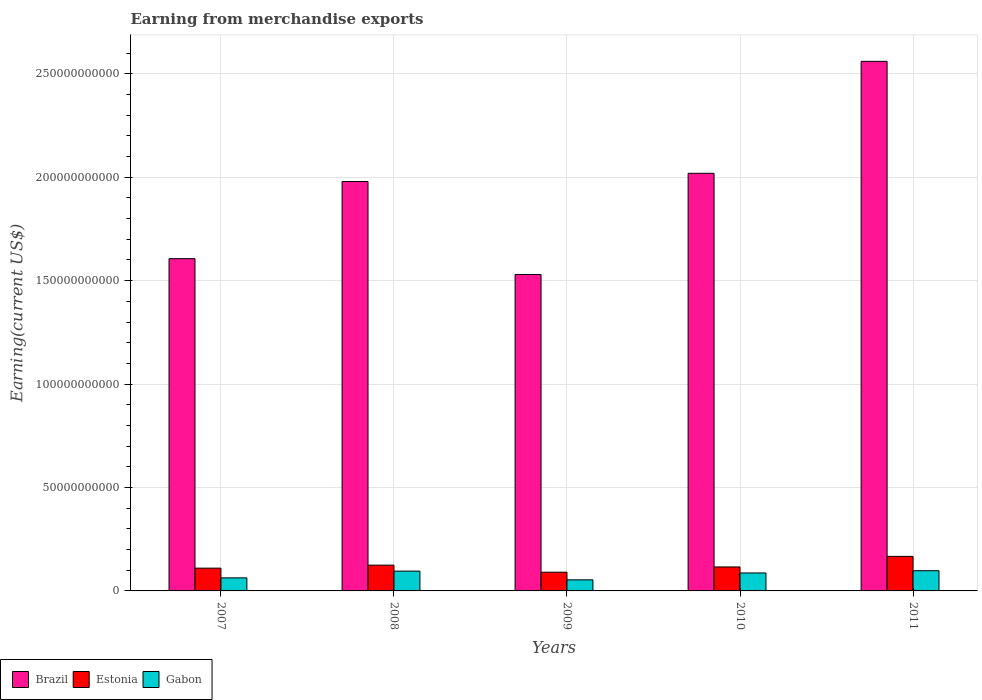How many groups of bars are there?
Provide a short and direct response. 5. Are the number of bars per tick equal to the number of legend labels?
Ensure brevity in your answer.  Yes. How many bars are there on the 2nd tick from the left?
Offer a very short reply. 3. What is the label of the 1st group of bars from the left?
Offer a very short reply. 2007. What is the amount earned from merchandise exports in Gabon in 2011?
Your response must be concise. 9.77e+09. Across all years, what is the maximum amount earned from merchandise exports in Gabon?
Ensure brevity in your answer.  9.77e+09. Across all years, what is the minimum amount earned from merchandise exports in Gabon?
Your answer should be compact. 5.36e+09. In which year was the amount earned from merchandise exports in Brazil maximum?
Offer a very short reply. 2011. What is the total amount earned from merchandise exports in Gabon in the graph?
Give a very brief answer. 3.97e+1. What is the difference between the amount earned from merchandise exports in Estonia in 2007 and that in 2008?
Provide a short and direct response. -1.45e+09. What is the difference between the amount earned from merchandise exports in Estonia in 2010 and the amount earned from merchandise exports in Gabon in 2009?
Your answer should be compact. 6.23e+09. What is the average amount earned from merchandise exports in Gabon per year?
Your answer should be compact. 7.94e+09. In the year 2009, what is the difference between the amount earned from merchandise exports in Estonia and amount earned from merchandise exports in Gabon?
Ensure brevity in your answer.  3.69e+09. What is the ratio of the amount earned from merchandise exports in Estonia in 2007 to that in 2009?
Provide a short and direct response. 1.22. Is the amount earned from merchandise exports in Brazil in 2007 less than that in 2011?
Your answer should be compact. Yes. Is the difference between the amount earned from merchandise exports in Estonia in 2008 and 2010 greater than the difference between the amount earned from merchandise exports in Gabon in 2008 and 2010?
Your response must be concise. No. What is the difference between the highest and the second highest amount earned from merchandise exports in Estonia?
Offer a terse response. 4.25e+09. What is the difference between the highest and the lowest amount earned from merchandise exports in Brazil?
Your response must be concise. 1.03e+11. In how many years, is the amount earned from merchandise exports in Gabon greater than the average amount earned from merchandise exports in Gabon taken over all years?
Provide a succinct answer. 3. Is the sum of the amount earned from merchandise exports in Gabon in 2007 and 2008 greater than the maximum amount earned from merchandise exports in Brazil across all years?
Offer a very short reply. No. What does the 1st bar from the left in 2010 represents?
Your response must be concise. Brazil. Are the values on the major ticks of Y-axis written in scientific E-notation?
Your response must be concise. No. Does the graph contain grids?
Your answer should be very brief. Yes. Where does the legend appear in the graph?
Ensure brevity in your answer.  Bottom left. How many legend labels are there?
Give a very brief answer. 3. What is the title of the graph?
Make the answer very short. Earning from merchandise exports. Does "Portugal" appear as one of the legend labels in the graph?
Keep it short and to the point. No. What is the label or title of the Y-axis?
Your answer should be very brief. Earning(current US$). What is the Earning(current US$) of Brazil in 2007?
Keep it short and to the point. 1.61e+11. What is the Earning(current US$) in Estonia in 2007?
Your answer should be very brief. 1.10e+1. What is the Earning(current US$) in Gabon in 2007?
Provide a short and direct response. 6.31e+09. What is the Earning(current US$) in Brazil in 2008?
Your answer should be very brief. 1.98e+11. What is the Earning(current US$) of Estonia in 2008?
Keep it short and to the point. 1.25e+1. What is the Earning(current US$) of Gabon in 2008?
Your response must be concise. 9.57e+09. What is the Earning(current US$) in Brazil in 2009?
Offer a terse response. 1.53e+11. What is the Earning(current US$) of Estonia in 2009?
Provide a short and direct response. 9.05e+09. What is the Earning(current US$) in Gabon in 2009?
Your answer should be compact. 5.36e+09. What is the Earning(current US$) of Brazil in 2010?
Ensure brevity in your answer.  2.02e+11. What is the Earning(current US$) in Estonia in 2010?
Your answer should be very brief. 1.16e+1. What is the Earning(current US$) of Gabon in 2010?
Keep it short and to the point. 8.69e+09. What is the Earning(current US$) of Brazil in 2011?
Your answer should be compact. 2.56e+11. What is the Earning(current US$) of Estonia in 2011?
Give a very brief answer. 1.67e+1. What is the Earning(current US$) in Gabon in 2011?
Your answer should be very brief. 9.77e+09. Across all years, what is the maximum Earning(current US$) of Brazil?
Your answer should be compact. 2.56e+11. Across all years, what is the maximum Earning(current US$) in Estonia?
Your answer should be very brief. 1.67e+1. Across all years, what is the maximum Earning(current US$) of Gabon?
Ensure brevity in your answer.  9.77e+09. Across all years, what is the minimum Earning(current US$) in Brazil?
Your answer should be compact. 1.53e+11. Across all years, what is the minimum Earning(current US$) of Estonia?
Offer a terse response. 9.05e+09. Across all years, what is the minimum Earning(current US$) of Gabon?
Ensure brevity in your answer.  5.36e+09. What is the total Earning(current US$) of Brazil in the graph?
Provide a short and direct response. 9.70e+11. What is the total Earning(current US$) in Estonia in the graph?
Provide a succinct answer. 6.08e+1. What is the total Earning(current US$) in Gabon in the graph?
Make the answer very short. 3.97e+1. What is the difference between the Earning(current US$) in Brazil in 2007 and that in 2008?
Your response must be concise. -3.73e+1. What is the difference between the Earning(current US$) in Estonia in 2007 and that in 2008?
Your answer should be compact. -1.45e+09. What is the difference between the Earning(current US$) of Gabon in 2007 and that in 2008?
Offer a terse response. -3.26e+09. What is the difference between the Earning(current US$) of Brazil in 2007 and that in 2009?
Give a very brief answer. 7.65e+09. What is the difference between the Earning(current US$) of Estonia in 2007 and that in 2009?
Give a very brief answer. 1.96e+09. What is the difference between the Earning(current US$) in Gabon in 2007 and that in 2009?
Your answer should be compact. 9.53e+08. What is the difference between the Earning(current US$) of Brazil in 2007 and that in 2010?
Your response must be concise. -4.13e+1. What is the difference between the Earning(current US$) of Estonia in 2007 and that in 2010?
Your answer should be very brief. -5.81e+08. What is the difference between the Earning(current US$) in Gabon in 2007 and that in 2010?
Give a very brief answer. -2.38e+09. What is the difference between the Earning(current US$) in Brazil in 2007 and that in 2011?
Offer a very short reply. -9.54e+1. What is the difference between the Earning(current US$) in Estonia in 2007 and that in 2011?
Your response must be concise. -5.70e+09. What is the difference between the Earning(current US$) of Gabon in 2007 and that in 2011?
Make the answer very short. -3.46e+09. What is the difference between the Earning(current US$) of Brazil in 2008 and that in 2009?
Provide a short and direct response. 4.49e+1. What is the difference between the Earning(current US$) of Estonia in 2008 and that in 2009?
Your response must be concise. 3.41e+09. What is the difference between the Earning(current US$) of Gabon in 2008 and that in 2009?
Your response must be concise. 4.21e+09. What is the difference between the Earning(current US$) of Brazil in 2008 and that in 2010?
Make the answer very short. -3.97e+09. What is the difference between the Earning(current US$) of Estonia in 2008 and that in 2010?
Make the answer very short. 8.67e+08. What is the difference between the Earning(current US$) in Gabon in 2008 and that in 2010?
Keep it short and to the point. 8.80e+08. What is the difference between the Earning(current US$) in Brazil in 2008 and that in 2011?
Your answer should be very brief. -5.81e+1. What is the difference between the Earning(current US$) in Estonia in 2008 and that in 2011?
Your response must be concise. -4.25e+09. What is the difference between the Earning(current US$) of Gabon in 2008 and that in 2011?
Give a very brief answer. -2.00e+08. What is the difference between the Earning(current US$) in Brazil in 2009 and that in 2010?
Offer a terse response. -4.89e+1. What is the difference between the Earning(current US$) in Estonia in 2009 and that in 2010?
Give a very brief answer. -2.54e+09. What is the difference between the Earning(current US$) in Gabon in 2009 and that in 2010?
Keep it short and to the point. -3.33e+09. What is the difference between the Earning(current US$) of Brazil in 2009 and that in 2011?
Provide a short and direct response. -1.03e+11. What is the difference between the Earning(current US$) in Estonia in 2009 and that in 2011?
Your answer should be very brief. -7.66e+09. What is the difference between the Earning(current US$) of Gabon in 2009 and that in 2011?
Provide a short and direct response. -4.41e+09. What is the difference between the Earning(current US$) of Brazil in 2010 and that in 2011?
Provide a short and direct response. -5.41e+1. What is the difference between the Earning(current US$) in Estonia in 2010 and that in 2011?
Provide a short and direct response. -5.12e+09. What is the difference between the Earning(current US$) of Gabon in 2010 and that in 2011?
Ensure brevity in your answer.  -1.08e+09. What is the difference between the Earning(current US$) of Brazil in 2007 and the Earning(current US$) of Estonia in 2008?
Give a very brief answer. 1.48e+11. What is the difference between the Earning(current US$) of Brazil in 2007 and the Earning(current US$) of Gabon in 2008?
Ensure brevity in your answer.  1.51e+11. What is the difference between the Earning(current US$) of Estonia in 2007 and the Earning(current US$) of Gabon in 2008?
Your answer should be very brief. 1.44e+09. What is the difference between the Earning(current US$) in Brazil in 2007 and the Earning(current US$) in Estonia in 2009?
Make the answer very short. 1.52e+11. What is the difference between the Earning(current US$) of Brazil in 2007 and the Earning(current US$) of Gabon in 2009?
Your answer should be compact. 1.55e+11. What is the difference between the Earning(current US$) of Estonia in 2007 and the Earning(current US$) of Gabon in 2009?
Your answer should be compact. 5.65e+09. What is the difference between the Earning(current US$) in Brazil in 2007 and the Earning(current US$) in Estonia in 2010?
Your response must be concise. 1.49e+11. What is the difference between the Earning(current US$) in Brazil in 2007 and the Earning(current US$) in Gabon in 2010?
Make the answer very short. 1.52e+11. What is the difference between the Earning(current US$) of Estonia in 2007 and the Earning(current US$) of Gabon in 2010?
Your answer should be very brief. 2.32e+09. What is the difference between the Earning(current US$) of Brazil in 2007 and the Earning(current US$) of Estonia in 2011?
Offer a terse response. 1.44e+11. What is the difference between the Earning(current US$) in Brazil in 2007 and the Earning(current US$) in Gabon in 2011?
Offer a very short reply. 1.51e+11. What is the difference between the Earning(current US$) in Estonia in 2007 and the Earning(current US$) in Gabon in 2011?
Provide a succinct answer. 1.24e+09. What is the difference between the Earning(current US$) in Brazil in 2008 and the Earning(current US$) in Estonia in 2009?
Offer a very short reply. 1.89e+11. What is the difference between the Earning(current US$) in Brazil in 2008 and the Earning(current US$) in Gabon in 2009?
Provide a short and direct response. 1.93e+11. What is the difference between the Earning(current US$) in Estonia in 2008 and the Earning(current US$) in Gabon in 2009?
Provide a short and direct response. 7.10e+09. What is the difference between the Earning(current US$) in Brazil in 2008 and the Earning(current US$) in Estonia in 2010?
Provide a succinct answer. 1.86e+11. What is the difference between the Earning(current US$) of Brazil in 2008 and the Earning(current US$) of Gabon in 2010?
Your answer should be very brief. 1.89e+11. What is the difference between the Earning(current US$) of Estonia in 2008 and the Earning(current US$) of Gabon in 2010?
Your answer should be very brief. 3.77e+09. What is the difference between the Earning(current US$) of Brazil in 2008 and the Earning(current US$) of Estonia in 2011?
Your answer should be very brief. 1.81e+11. What is the difference between the Earning(current US$) in Brazil in 2008 and the Earning(current US$) in Gabon in 2011?
Your response must be concise. 1.88e+11. What is the difference between the Earning(current US$) of Estonia in 2008 and the Earning(current US$) of Gabon in 2011?
Keep it short and to the point. 2.69e+09. What is the difference between the Earning(current US$) of Brazil in 2009 and the Earning(current US$) of Estonia in 2010?
Offer a very short reply. 1.41e+11. What is the difference between the Earning(current US$) in Brazil in 2009 and the Earning(current US$) in Gabon in 2010?
Provide a succinct answer. 1.44e+11. What is the difference between the Earning(current US$) in Estonia in 2009 and the Earning(current US$) in Gabon in 2010?
Ensure brevity in your answer.  3.62e+08. What is the difference between the Earning(current US$) in Brazil in 2009 and the Earning(current US$) in Estonia in 2011?
Your answer should be very brief. 1.36e+11. What is the difference between the Earning(current US$) in Brazil in 2009 and the Earning(current US$) in Gabon in 2011?
Keep it short and to the point. 1.43e+11. What is the difference between the Earning(current US$) of Estonia in 2009 and the Earning(current US$) of Gabon in 2011?
Offer a very short reply. -7.18e+08. What is the difference between the Earning(current US$) in Brazil in 2010 and the Earning(current US$) in Estonia in 2011?
Offer a very short reply. 1.85e+11. What is the difference between the Earning(current US$) in Brazil in 2010 and the Earning(current US$) in Gabon in 2011?
Your answer should be very brief. 1.92e+11. What is the difference between the Earning(current US$) of Estonia in 2010 and the Earning(current US$) of Gabon in 2011?
Make the answer very short. 1.83e+09. What is the average Earning(current US$) of Brazil per year?
Provide a succinct answer. 1.94e+11. What is the average Earning(current US$) in Estonia per year?
Offer a very short reply. 1.22e+1. What is the average Earning(current US$) of Gabon per year?
Your answer should be very brief. 7.94e+09. In the year 2007, what is the difference between the Earning(current US$) in Brazil and Earning(current US$) in Estonia?
Give a very brief answer. 1.50e+11. In the year 2007, what is the difference between the Earning(current US$) in Brazil and Earning(current US$) in Gabon?
Keep it short and to the point. 1.54e+11. In the year 2007, what is the difference between the Earning(current US$) of Estonia and Earning(current US$) of Gabon?
Offer a very short reply. 4.70e+09. In the year 2008, what is the difference between the Earning(current US$) of Brazil and Earning(current US$) of Estonia?
Give a very brief answer. 1.85e+11. In the year 2008, what is the difference between the Earning(current US$) in Brazil and Earning(current US$) in Gabon?
Keep it short and to the point. 1.88e+11. In the year 2008, what is the difference between the Earning(current US$) of Estonia and Earning(current US$) of Gabon?
Provide a short and direct response. 2.89e+09. In the year 2009, what is the difference between the Earning(current US$) in Brazil and Earning(current US$) in Estonia?
Keep it short and to the point. 1.44e+11. In the year 2009, what is the difference between the Earning(current US$) of Brazil and Earning(current US$) of Gabon?
Provide a succinct answer. 1.48e+11. In the year 2009, what is the difference between the Earning(current US$) of Estonia and Earning(current US$) of Gabon?
Offer a terse response. 3.69e+09. In the year 2010, what is the difference between the Earning(current US$) of Brazil and Earning(current US$) of Estonia?
Provide a succinct answer. 1.90e+11. In the year 2010, what is the difference between the Earning(current US$) in Brazil and Earning(current US$) in Gabon?
Offer a terse response. 1.93e+11. In the year 2010, what is the difference between the Earning(current US$) of Estonia and Earning(current US$) of Gabon?
Your answer should be very brief. 2.90e+09. In the year 2011, what is the difference between the Earning(current US$) of Brazil and Earning(current US$) of Estonia?
Offer a very short reply. 2.39e+11. In the year 2011, what is the difference between the Earning(current US$) of Brazil and Earning(current US$) of Gabon?
Keep it short and to the point. 2.46e+11. In the year 2011, what is the difference between the Earning(current US$) of Estonia and Earning(current US$) of Gabon?
Give a very brief answer. 6.94e+09. What is the ratio of the Earning(current US$) of Brazil in 2007 to that in 2008?
Your answer should be compact. 0.81. What is the ratio of the Earning(current US$) of Estonia in 2007 to that in 2008?
Your response must be concise. 0.88. What is the ratio of the Earning(current US$) of Gabon in 2007 to that in 2008?
Ensure brevity in your answer.  0.66. What is the ratio of the Earning(current US$) in Estonia in 2007 to that in 2009?
Keep it short and to the point. 1.22. What is the ratio of the Earning(current US$) in Gabon in 2007 to that in 2009?
Ensure brevity in your answer.  1.18. What is the ratio of the Earning(current US$) of Brazil in 2007 to that in 2010?
Ensure brevity in your answer.  0.8. What is the ratio of the Earning(current US$) of Estonia in 2007 to that in 2010?
Keep it short and to the point. 0.95. What is the ratio of the Earning(current US$) in Gabon in 2007 to that in 2010?
Provide a short and direct response. 0.73. What is the ratio of the Earning(current US$) in Brazil in 2007 to that in 2011?
Provide a short and direct response. 0.63. What is the ratio of the Earning(current US$) in Estonia in 2007 to that in 2011?
Your answer should be very brief. 0.66. What is the ratio of the Earning(current US$) of Gabon in 2007 to that in 2011?
Offer a terse response. 0.65. What is the ratio of the Earning(current US$) in Brazil in 2008 to that in 2009?
Provide a succinct answer. 1.29. What is the ratio of the Earning(current US$) in Estonia in 2008 to that in 2009?
Provide a short and direct response. 1.38. What is the ratio of the Earning(current US$) of Gabon in 2008 to that in 2009?
Your answer should be compact. 1.79. What is the ratio of the Earning(current US$) of Brazil in 2008 to that in 2010?
Your answer should be compact. 0.98. What is the ratio of the Earning(current US$) of Estonia in 2008 to that in 2010?
Your answer should be compact. 1.07. What is the ratio of the Earning(current US$) of Gabon in 2008 to that in 2010?
Make the answer very short. 1.1. What is the ratio of the Earning(current US$) of Brazil in 2008 to that in 2011?
Your response must be concise. 0.77. What is the ratio of the Earning(current US$) in Estonia in 2008 to that in 2011?
Provide a succinct answer. 0.75. What is the ratio of the Earning(current US$) of Gabon in 2008 to that in 2011?
Provide a short and direct response. 0.98. What is the ratio of the Earning(current US$) in Brazil in 2009 to that in 2010?
Your answer should be compact. 0.76. What is the ratio of the Earning(current US$) in Estonia in 2009 to that in 2010?
Offer a terse response. 0.78. What is the ratio of the Earning(current US$) in Gabon in 2009 to that in 2010?
Make the answer very short. 0.62. What is the ratio of the Earning(current US$) in Brazil in 2009 to that in 2011?
Your answer should be very brief. 0.6. What is the ratio of the Earning(current US$) of Estonia in 2009 to that in 2011?
Your answer should be compact. 0.54. What is the ratio of the Earning(current US$) in Gabon in 2009 to that in 2011?
Your answer should be very brief. 0.55. What is the ratio of the Earning(current US$) of Brazil in 2010 to that in 2011?
Your response must be concise. 0.79. What is the ratio of the Earning(current US$) in Estonia in 2010 to that in 2011?
Give a very brief answer. 0.69. What is the ratio of the Earning(current US$) of Gabon in 2010 to that in 2011?
Your response must be concise. 0.89. What is the difference between the highest and the second highest Earning(current US$) of Brazil?
Your response must be concise. 5.41e+1. What is the difference between the highest and the second highest Earning(current US$) of Estonia?
Offer a terse response. 4.25e+09. What is the difference between the highest and the second highest Earning(current US$) in Gabon?
Your response must be concise. 2.00e+08. What is the difference between the highest and the lowest Earning(current US$) of Brazil?
Offer a very short reply. 1.03e+11. What is the difference between the highest and the lowest Earning(current US$) of Estonia?
Offer a very short reply. 7.66e+09. What is the difference between the highest and the lowest Earning(current US$) of Gabon?
Keep it short and to the point. 4.41e+09. 